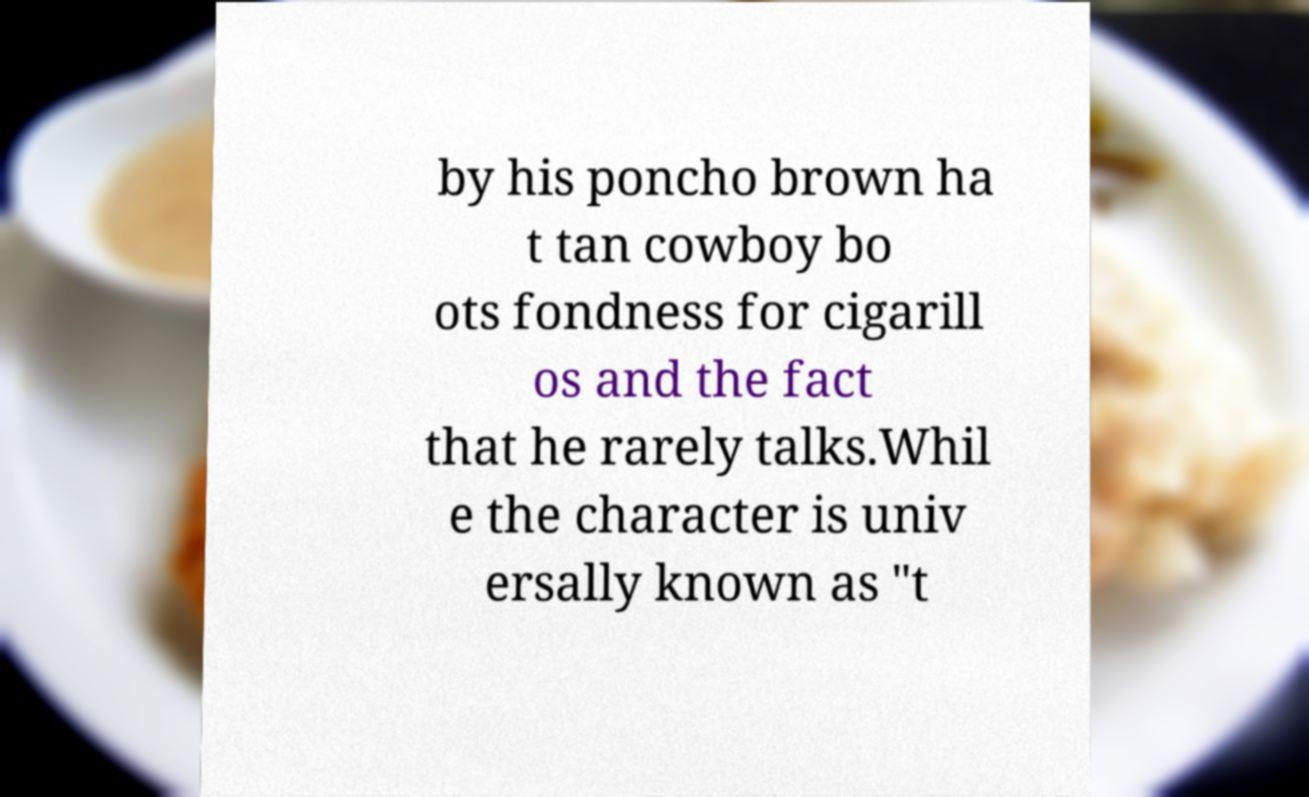Can you accurately transcribe the text from the provided image for me? by his poncho brown ha t tan cowboy bo ots fondness for cigarill os and the fact that he rarely talks.Whil e the character is univ ersally known as "t 